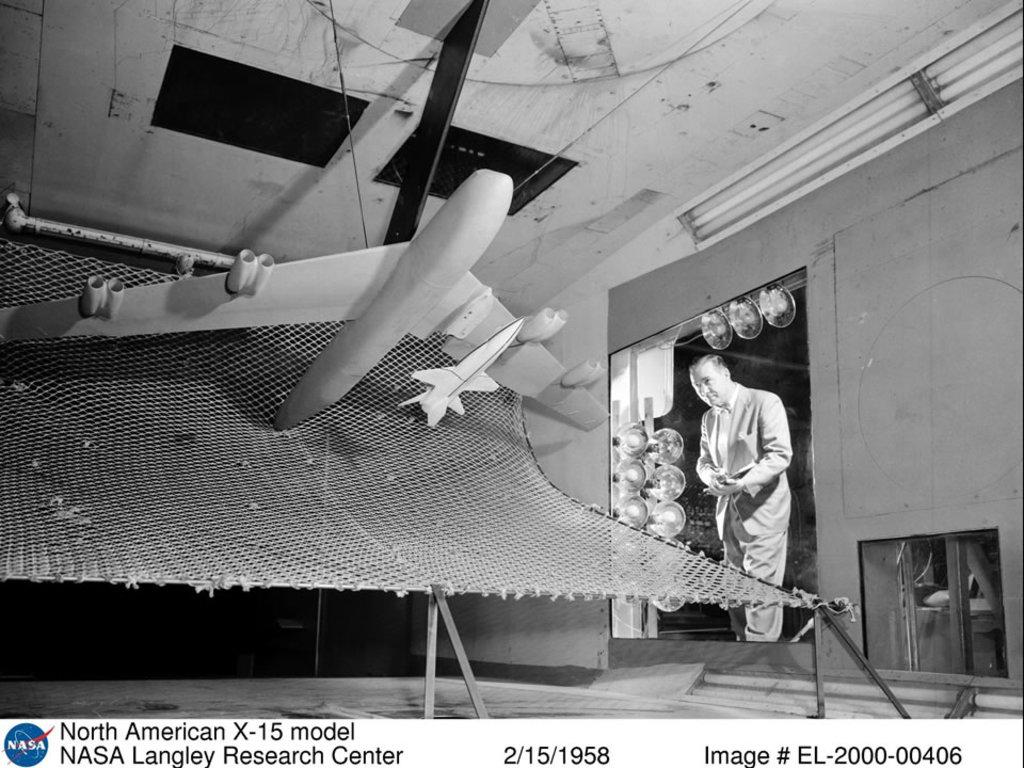What company is in the photo?
Give a very brief answer. Nasa. What is the date on the photo?
Give a very brief answer. 2/15/1958. 